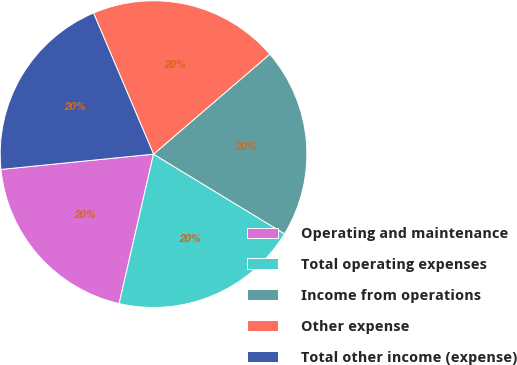Convert chart. <chart><loc_0><loc_0><loc_500><loc_500><pie_chart><fcel>Operating and maintenance<fcel>Total operating expenses<fcel>Income from operations<fcel>Other expense<fcel>Total other income (expense)<nl><fcel>19.81%<fcel>19.9%<fcel>20.0%<fcel>20.1%<fcel>20.19%<nl></chart> 